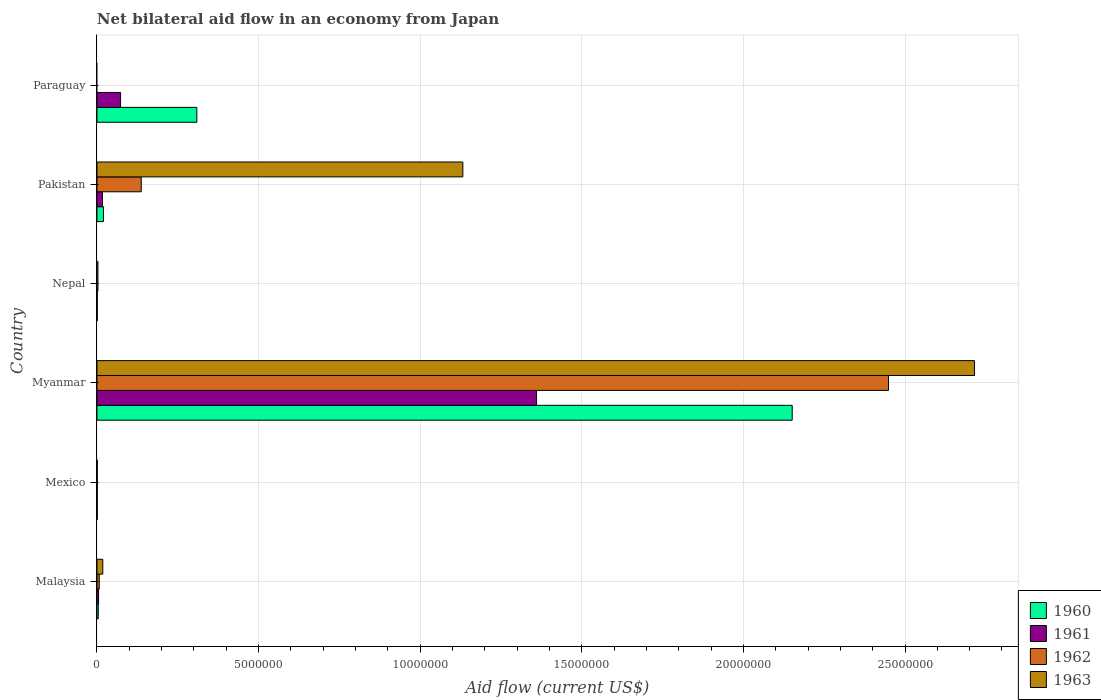Are the number of bars on each tick of the Y-axis equal?
Offer a very short reply. No. How many bars are there on the 5th tick from the top?
Keep it short and to the point. 4. How many bars are there on the 5th tick from the bottom?
Your answer should be compact. 4. What is the label of the 4th group of bars from the top?
Make the answer very short. Myanmar. In how many cases, is the number of bars for a given country not equal to the number of legend labels?
Make the answer very short. 1. What is the net bilateral aid flow in 1961 in Paraguay?
Give a very brief answer. 7.30e+05. Across all countries, what is the maximum net bilateral aid flow in 1960?
Make the answer very short. 2.15e+07. In which country was the net bilateral aid flow in 1960 maximum?
Provide a succinct answer. Myanmar. What is the total net bilateral aid flow in 1962 in the graph?
Give a very brief answer. 2.60e+07. What is the difference between the net bilateral aid flow in 1961 in Myanmar and the net bilateral aid flow in 1960 in Pakistan?
Your answer should be compact. 1.34e+07. What is the average net bilateral aid flow in 1961 per country?
Provide a short and direct response. 2.43e+06. What is the difference between the net bilateral aid flow in 1962 and net bilateral aid flow in 1960 in Myanmar?
Your answer should be compact. 2.98e+06. What is the ratio of the net bilateral aid flow in 1961 in Malaysia to that in Myanmar?
Your answer should be very brief. 0. Is the difference between the net bilateral aid flow in 1962 in Malaysia and Mexico greater than the difference between the net bilateral aid flow in 1960 in Malaysia and Mexico?
Your answer should be very brief. Yes. What is the difference between the highest and the second highest net bilateral aid flow in 1962?
Offer a very short reply. 2.31e+07. What is the difference between the highest and the lowest net bilateral aid flow in 1962?
Provide a short and direct response. 2.45e+07. In how many countries, is the net bilateral aid flow in 1960 greater than the average net bilateral aid flow in 1960 taken over all countries?
Your response must be concise. 1. Is it the case that in every country, the sum of the net bilateral aid flow in 1963 and net bilateral aid flow in 1962 is greater than the sum of net bilateral aid flow in 1961 and net bilateral aid flow in 1960?
Your answer should be very brief. No. How many bars are there?
Your answer should be compact. 22. Are all the bars in the graph horizontal?
Your answer should be compact. Yes. How many countries are there in the graph?
Provide a short and direct response. 6. What is the difference between two consecutive major ticks on the X-axis?
Your response must be concise. 5.00e+06. Does the graph contain any zero values?
Provide a succinct answer. Yes. Does the graph contain grids?
Your response must be concise. Yes. Where does the legend appear in the graph?
Provide a short and direct response. Bottom right. How many legend labels are there?
Ensure brevity in your answer.  4. How are the legend labels stacked?
Provide a succinct answer. Vertical. What is the title of the graph?
Your answer should be compact. Net bilateral aid flow in an economy from Japan. Does "1991" appear as one of the legend labels in the graph?
Keep it short and to the point. No. What is the label or title of the X-axis?
Provide a short and direct response. Aid flow (current US$). What is the label or title of the Y-axis?
Your response must be concise. Country. What is the Aid flow (current US$) in 1960 in Malaysia?
Give a very brief answer. 4.00e+04. What is the Aid flow (current US$) in 1962 in Malaysia?
Your answer should be compact. 7.00e+04. What is the Aid flow (current US$) in 1963 in Mexico?
Your answer should be very brief. 10000. What is the Aid flow (current US$) of 1960 in Myanmar?
Ensure brevity in your answer.  2.15e+07. What is the Aid flow (current US$) in 1961 in Myanmar?
Offer a very short reply. 1.36e+07. What is the Aid flow (current US$) in 1962 in Myanmar?
Provide a short and direct response. 2.45e+07. What is the Aid flow (current US$) in 1963 in Myanmar?
Your answer should be very brief. 2.72e+07. What is the Aid flow (current US$) of 1961 in Nepal?
Your response must be concise. 10000. What is the Aid flow (current US$) in 1963 in Nepal?
Provide a succinct answer. 3.00e+04. What is the Aid flow (current US$) in 1960 in Pakistan?
Provide a short and direct response. 2.00e+05. What is the Aid flow (current US$) in 1962 in Pakistan?
Your answer should be very brief. 1.37e+06. What is the Aid flow (current US$) in 1963 in Pakistan?
Your answer should be very brief. 1.13e+07. What is the Aid flow (current US$) of 1960 in Paraguay?
Provide a short and direct response. 3.09e+06. What is the Aid flow (current US$) of 1961 in Paraguay?
Your answer should be very brief. 7.30e+05. What is the Aid flow (current US$) in 1962 in Paraguay?
Your response must be concise. 0. Across all countries, what is the maximum Aid flow (current US$) of 1960?
Make the answer very short. 2.15e+07. Across all countries, what is the maximum Aid flow (current US$) in 1961?
Your answer should be very brief. 1.36e+07. Across all countries, what is the maximum Aid flow (current US$) of 1962?
Your response must be concise. 2.45e+07. Across all countries, what is the maximum Aid flow (current US$) in 1963?
Give a very brief answer. 2.72e+07. Across all countries, what is the minimum Aid flow (current US$) of 1961?
Provide a succinct answer. 10000. What is the total Aid flow (current US$) in 1960 in the graph?
Your answer should be very brief. 2.49e+07. What is the total Aid flow (current US$) of 1961 in the graph?
Your answer should be very brief. 1.46e+07. What is the total Aid flow (current US$) in 1962 in the graph?
Make the answer very short. 2.60e+07. What is the total Aid flow (current US$) of 1963 in the graph?
Provide a succinct answer. 3.87e+07. What is the difference between the Aid flow (current US$) of 1960 in Malaysia and that in Mexico?
Your answer should be compact. 3.00e+04. What is the difference between the Aid flow (current US$) of 1962 in Malaysia and that in Mexico?
Give a very brief answer. 6.00e+04. What is the difference between the Aid flow (current US$) in 1963 in Malaysia and that in Mexico?
Give a very brief answer. 1.70e+05. What is the difference between the Aid flow (current US$) in 1960 in Malaysia and that in Myanmar?
Keep it short and to the point. -2.15e+07. What is the difference between the Aid flow (current US$) in 1961 in Malaysia and that in Myanmar?
Make the answer very short. -1.36e+07. What is the difference between the Aid flow (current US$) in 1962 in Malaysia and that in Myanmar?
Make the answer very short. -2.44e+07. What is the difference between the Aid flow (current US$) in 1963 in Malaysia and that in Myanmar?
Make the answer very short. -2.70e+07. What is the difference between the Aid flow (current US$) of 1963 in Malaysia and that in Nepal?
Offer a very short reply. 1.50e+05. What is the difference between the Aid flow (current US$) in 1962 in Malaysia and that in Pakistan?
Ensure brevity in your answer.  -1.30e+06. What is the difference between the Aid flow (current US$) in 1963 in Malaysia and that in Pakistan?
Keep it short and to the point. -1.11e+07. What is the difference between the Aid flow (current US$) in 1960 in Malaysia and that in Paraguay?
Your answer should be compact. -3.05e+06. What is the difference between the Aid flow (current US$) of 1961 in Malaysia and that in Paraguay?
Your response must be concise. -6.80e+05. What is the difference between the Aid flow (current US$) in 1960 in Mexico and that in Myanmar?
Provide a succinct answer. -2.15e+07. What is the difference between the Aid flow (current US$) in 1961 in Mexico and that in Myanmar?
Make the answer very short. -1.36e+07. What is the difference between the Aid flow (current US$) in 1962 in Mexico and that in Myanmar?
Keep it short and to the point. -2.45e+07. What is the difference between the Aid flow (current US$) in 1963 in Mexico and that in Myanmar?
Make the answer very short. -2.71e+07. What is the difference between the Aid flow (current US$) in 1960 in Mexico and that in Nepal?
Your answer should be very brief. 0. What is the difference between the Aid flow (current US$) in 1962 in Mexico and that in Nepal?
Ensure brevity in your answer.  -2.00e+04. What is the difference between the Aid flow (current US$) of 1961 in Mexico and that in Pakistan?
Offer a terse response. -1.60e+05. What is the difference between the Aid flow (current US$) of 1962 in Mexico and that in Pakistan?
Provide a short and direct response. -1.36e+06. What is the difference between the Aid flow (current US$) in 1963 in Mexico and that in Pakistan?
Make the answer very short. -1.13e+07. What is the difference between the Aid flow (current US$) of 1960 in Mexico and that in Paraguay?
Offer a very short reply. -3.08e+06. What is the difference between the Aid flow (current US$) of 1961 in Mexico and that in Paraguay?
Make the answer very short. -7.20e+05. What is the difference between the Aid flow (current US$) of 1960 in Myanmar and that in Nepal?
Provide a short and direct response. 2.15e+07. What is the difference between the Aid flow (current US$) of 1961 in Myanmar and that in Nepal?
Give a very brief answer. 1.36e+07. What is the difference between the Aid flow (current US$) of 1962 in Myanmar and that in Nepal?
Your response must be concise. 2.45e+07. What is the difference between the Aid flow (current US$) of 1963 in Myanmar and that in Nepal?
Keep it short and to the point. 2.71e+07. What is the difference between the Aid flow (current US$) of 1960 in Myanmar and that in Pakistan?
Provide a succinct answer. 2.13e+07. What is the difference between the Aid flow (current US$) of 1961 in Myanmar and that in Pakistan?
Give a very brief answer. 1.34e+07. What is the difference between the Aid flow (current US$) in 1962 in Myanmar and that in Pakistan?
Make the answer very short. 2.31e+07. What is the difference between the Aid flow (current US$) in 1963 in Myanmar and that in Pakistan?
Your response must be concise. 1.58e+07. What is the difference between the Aid flow (current US$) of 1960 in Myanmar and that in Paraguay?
Keep it short and to the point. 1.84e+07. What is the difference between the Aid flow (current US$) in 1961 in Myanmar and that in Paraguay?
Provide a succinct answer. 1.29e+07. What is the difference between the Aid flow (current US$) of 1960 in Nepal and that in Pakistan?
Give a very brief answer. -1.90e+05. What is the difference between the Aid flow (current US$) of 1962 in Nepal and that in Pakistan?
Provide a short and direct response. -1.34e+06. What is the difference between the Aid flow (current US$) of 1963 in Nepal and that in Pakistan?
Your response must be concise. -1.13e+07. What is the difference between the Aid flow (current US$) in 1960 in Nepal and that in Paraguay?
Your answer should be compact. -3.08e+06. What is the difference between the Aid flow (current US$) of 1961 in Nepal and that in Paraguay?
Your answer should be very brief. -7.20e+05. What is the difference between the Aid flow (current US$) of 1960 in Pakistan and that in Paraguay?
Make the answer very short. -2.89e+06. What is the difference between the Aid flow (current US$) of 1961 in Pakistan and that in Paraguay?
Your response must be concise. -5.60e+05. What is the difference between the Aid flow (current US$) of 1960 in Malaysia and the Aid flow (current US$) of 1961 in Mexico?
Your answer should be very brief. 3.00e+04. What is the difference between the Aid flow (current US$) of 1960 in Malaysia and the Aid flow (current US$) of 1962 in Mexico?
Offer a terse response. 3.00e+04. What is the difference between the Aid flow (current US$) in 1960 in Malaysia and the Aid flow (current US$) in 1963 in Mexico?
Your response must be concise. 3.00e+04. What is the difference between the Aid flow (current US$) in 1960 in Malaysia and the Aid flow (current US$) in 1961 in Myanmar?
Ensure brevity in your answer.  -1.36e+07. What is the difference between the Aid flow (current US$) in 1960 in Malaysia and the Aid flow (current US$) in 1962 in Myanmar?
Keep it short and to the point. -2.44e+07. What is the difference between the Aid flow (current US$) of 1960 in Malaysia and the Aid flow (current US$) of 1963 in Myanmar?
Your answer should be very brief. -2.71e+07. What is the difference between the Aid flow (current US$) in 1961 in Malaysia and the Aid flow (current US$) in 1962 in Myanmar?
Keep it short and to the point. -2.44e+07. What is the difference between the Aid flow (current US$) in 1961 in Malaysia and the Aid flow (current US$) in 1963 in Myanmar?
Offer a very short reply. -2.71e+07. What is the difference between the Aid flow (current US$) of 1962 in Malaysia and the Aid flow (current US$) of 1963 in Myanmar?
Provide a short and direct response. -2.71e+07. What is the difference between the Aid flow (current US$) in 1960 in Malaysia and the Aid flow (current US$) in 1961 in Nepal?
Provide a succinct answer. 3.00e+04. What is the difference between the Aid flow (current US$) of 1961 in Malaysia and the Aid flow (current US$) of 1963 in Nepal?
Give a very brief answer. 2.00e+04. What is the difference between the Aid flow (current US$) in 1962 in Malaysia and the Aid flow (current US$) in 1963 in Nepal?
Ensure brevity in your answer.  4.00e+04. What is the difference between the Aid flow (current US$) of 1960 in Malaysia and the Aid flow (current US$) of 1961 in Pakistan?
Provide a succinct answer. -1.30e+05. What is the difference between the Aid flow (current US$) of 1960 in Malaysia and the Aid flow (current US$) of 1962 in Pakistan?
Keep it short and to the point. -1.33e+06. What is the difference between the Aid flow (current US$) of 1960 in Malaysia and the Aid flow (current US$) of 1963 in Pakistan?
Your response must be concise. -1.13e+07. What is the difference between the Aid flow (current US$) in 1961 in Malaysia and the Aid flow (current US$) in 1962 in Pakistan?
Offer a very short reply. -1.32e+06. What is the difference between the Aid flow (current US$) of 1961 in Malaysia and the Aid flow (current US$) of 1963 in Pakistan?
Provide a short and direct response. -1.13e+07. What is the difference between the Aid flow (current US$) in 1962 in Malaysia and the Aid flow (current US$) in 1963 in Pakistan?
Your response must be concise. -1.12e+07. What is the difference between the Aid flow (current US$) in 1960 in Malaysia and the Aid flow (current US$) in 1961 in Paraguay?
Keep it short and to the point. -6.90e+05. What is the difference between the Aid flow (current US$) of 1960 in Mexico and the Aid flow (current US$) of 1961 in Myanmar?
Your answer should be compact. -1.36e+07. What is the difference between the Aid flow (current US$) of 1960 in Mexico and the Aid flow (current US$) of 1962 in Myanmar?
Your response must be concise. -2.45e+07. What is the difference between the Aid flow (current US$) in 1960 in Mexico and the Aid flow (current US$) in 1963 in Myanmar?
Your answer should be very brief. -2.71e+07. What is the difference between the Aid flow (current US$) of 1961 in Mexico and the Aid flow (current US$) of 1962 in Myanmar?
Provide a short and direct response. -2.45e+07. What is the difference between the Aid flow (current US$) in 1961 in Mexico and the Aid flow (current US$) in 1963 in Myanmar?
Ensure brevity in your answer.  -2.71e+07. What is the difference between the Aid flow (current US$) in 1962 in Mexico and the Aid flow (current US$) in 1963 in Myanmar?
Offer a very short reply. -2.71e+07. What is the difference between the Aid flow (current US$) in 1960 in Mexico and the Aid flow (current US$) in 1962 in Nepal?
Offer a very short reply. -2.00e+04. What is the difference between the Aid flow (current US$) in 1960 in Mexico and the Aid flow (current US$) in 1963 in Nepal?
Provide a succinct answer. -2.00e+04. What is the difference between the Aid flow (current US$) of 1961 in Mexico and the Aid flow (current US$) of 1963 in Nepal?
Your answer should be very brief. -2.00e+04. What is the difference between the Aid flow (current US$) in 1960 in Mexico and the Aid flow (current US$) in 1962 in Pakistan?
Offer a very short reply. -1.36e+06. What is the difference between the Aid flow (current US$) in 1960 in Mexico and the Aid flow (current US$) in 1963 in Pakistan?
Give a very brief answer. -1.13e+07. What is the difference between the Aid flow (current US$) of 1961 in Mexico and the Aid flow (current US$) of 1962 in Pakistan?
Offer a very short reply. -1.36e+06. What is the difference between the Aid flow (current US$) of 1961 in Mexico and the Aid flow (current US$) of 1963 in Pakistan?
Offer a very short reply. -1.13e+07. What is the difference between the Aid flow (current US$) in 1962 in Mexico and the Aid flow (current US$) in 1963 in Pakistan?
Ensure brevity in your answer.  -1.13e+07. What is the difference between the Aid flow (current US$) in 1960 in Mexico and the Aid flow (current US$) in 1961 in Paraguay?
Your answer should be very brief. -7.20e+05. What is the difference between the Aid flow (current US$) in 1960 in Myanmar and the Aid flow (current US$) in 1961 in Nepal?
Your answer should be very brief. 2.15e+07. What is the difference between the Aid flow (current US$) of 1960 in Myanmar and the Aid flow (current US$) of 1962 in Nepal?
Give a very brief answer. 2.15e+07. What is the difference between the Aid flow (current US$) of 1960 in Myanmar and the Aid flow (current US$) of 1963 in Nepal?
Your response must be concise. 2.15e+07. What is the difference between the Aid flow (current US$) of 1961 in Myanmar and the Aid flow (current US$) of 1962 in Nepal?
Provide a short and direct response. 1.36e+07. What is the difference between the Aid flow (current US$) in 1961 in Myanmar and the Aid flow (current US$) in 1963 in Nepal?
Give a very brief answer. 1.36e+07. What is the difference between the Aid flow (current US$) of 1962 in Myanmar and the Aid flow (current US$) of 1963 in Nepal?
Ensure brevity in your answer.  2.45e+07. What is the difference between the Aid flow (current US$) of 1960 in Myanmar and the Aid flow (current US$) of 1961 in Pakistan?
Keep it short and to the point. 2.13e+07. What is the difference between the Aid flow (current US$) of 1960 in Myanmar and the Aid flow (current US$) of 1962 in Pakistan?
Your answer should be very brief. 2.01e+07. What is the difference between the Aid flow (current US$) in 1960 in Myanmar and the Aid flow (current US$) in 1963 in Pakistan?
Your answer should be compact. 1.02e+07. What is the difference between the Aid flow (current US$) of 1961 in Myanmar and the Aid flow (current US$) of 1962 in Pakistan?
Offer a very short reply. 1.22e+07. What is the difference between the Aid flow (current US$) of 1961 in Myanmar and the Aid flow (current US$) of 1963 in Pakistan?
Ensure brevity in your answer.  2.28e+06. What is the difference between the Aid flow (current US$) in 1962 in Myanmar and the Aid flow (current US$) in 1963 in Pakistan?
Your answer should be compact. 1.32e+07. What is the difference between the Aid flow (current US$) in 1960 in Myanmar and the Aid flow (current US$) in 1961 in Paraguay?
Make the answer very short. 2.08e+07. What is the difference between the Aid flow (current US$) in 1960 in Nepal and the Aid flow (current US$) in 1961 in Pakistan?
Your answer should be very brief. -1.60e+05. What is the difference between the Aid flow (current US$) in 1960 in Nepal and the Aid flow (current US$) in 1962 in Pakistan?
Your answer should be compact. -1.36e+06. What is the difference between the Aid flow (current US$) of 1960 in Nepal and the Aid flow (current US$) of 1963 in Pakistan?
Offer a terse response. -1.13e+07. What is the difference between the Aid flow (current US$) of 1961 in Nepal and the Aid flow (current US$) of 1962 in Pakistan?
Offer a very short reply. -1.36e+06. What is the difference between the Aid flow (current US$) in 1961 in Nepal and the Aid flow (current US$) in 1963 in Pakistan?
Offer a very short reply. -1.13e+07. What is the difference between the Aid flow (current US$) of 1962 in Nepal and the Aid flow (current US$) of 1963 in Pakistan?
Ensure brevity in your answer.  -1.13e+07. What is the difference between the Aid flow (current US$) of 1960 in Nepal and the Aid flow (current US$) of 1961 in Paraguay?
Offer a terse response. -7.20e+05. What is the difference between the Aid flow (current US$) in 1960 in Pakistan and the Aid flow (current US$) in 1961 in Paraguay?
Your response must be concise. -5.30e+05. What is the average Aid flow (current US$) in 1960 per country?
Give a very brief answer. 4.14e+06. What is the average Aid flow (current US$) in 1961 per country?
Make the answer very short. 2.43e+06. What is the average Aid flow (current US$) of 1962 per country?
Your answer should be very brief. 4.33e+06. What is the average Aid flow (current US$) of 1963 per country?
Give a very brief answer. 6.45e+06. What is the difference between the Aid flow (current US$) of 1960 and Aid flow (current US$) of 1963 in Malaysia?
Give a very brief answer. -1.40e+05. What is the difference between the Aid flow (current US$) in 1962 and Aid flow (current US$) in 1963 in Malaysia?
Give a very brief answer. -1.10e+05. What is the difference between the Aid flow (current US$) of 1960 and Aid flow (current US$) of 1961 in Mexico?
Your answer should be very brief. 0. What is the difference between the Aid flow (current US$) of 1960 and Aid flow (current US$) of 1962 in Mexico?
Provide a short and direct response. 0. What is the difference between the Aid flow (current US$) in 1960 and Aid flow (current US$) in 1963 in Mexico?
Your answer should be compact. 0. What is the difference between the Aid flow (current US$) of 1961 and Aid flow (current US$) of 1962 in Mexico?
Offer a very short reply. 0. What is the difference between the Aid flow (current US$) of 1961 and Aid flow (current US$) of 1963 in Mexico?
Your response must be concise. 0. What is the difference between the Aid flow (current US$) of 1960 and Aid flow (current US$) of 1961 in Myanmar?
Provide a succinct answer. 7.91e+06. What is the difference between the Aid flow (current US$) of 1960 and Aid flow (current US$) of 1962 in Myanmar?
Your answer should be compact. -2.98e+06. What is the difference between the Aid flow (current US$) of 1960 and Aid flow (current US$) of 1963 in Myanmar?
Offer a very short reply. -5.64e+06. What is the difference between the Aid flow (current US$) in 1961 and Aid flow (current US$) in 1962 in Myanmar?
Your answer should be compact. -1.09e+07. What is the difference between the Aid flow (current US$) of 1961 and Aid flow (current US$) of 1963 in Myanmar?
Offer a terse response. -1.36e+07. What is the difference between the Aid flow (current US$) of 1962 and Aid flow (current US$) of 1963 in Myanmar?
Keep it short and to the point. -2.66e+06. What is the difference between the Aid flow (current US$) of 1960 and Aid flow (current US$) of 1961 in Nepal?
Your response must be concise. 0. What is the difference between the Aid flow (current US$) of 1961 and Aid flow (current US$) of 1962 in Nepal?
Give a very brief answer. -2.00e+04. What is the difference between the Aid flow (current US$) in 1962 and Aid flow (current US$) in 1963 in Nepal?
Make the answer very short. 0. What is the difference between the Aid flow (current US$) of 1960 and Aid flow (current US$) of 1961 in Pakistan?
Your answer should be compact. 3.00e+04. What is the difference between the Aid flow (current US$) of 1960 and Aid flow (current US$) of 1962 in Pakistan?
Provide a short and direct response. -1.17e+06. What is the difference between the Aid flow (current US$) of 1960 and Aid flow (current US$) of 1963 in Pakistan?
Provide a short and direct response. -1.11e+07. What is the difference between the Aid flow (current US$) of 1961 and Aid flow (current US$) of 1962 in Pakistan?
Ensure brevity in your answer.  -1.20e+06. What is the difference between the Aid flow (current US$) in 1961 and Aid flow (current US$) in 1963 in Pakistan?
Provide a succinct answer. -1.12e+07. What is the difference between the Aid flow (current US$) in 1962 and Aid flow (current US$) in 1963 in Pakistan?
Ensure brevity in your answer.  -9.95e+06. What is the difference between the Aid flow (current US$) of 1960 and Aid flow (current US$) of 1961 in Paraguay?
Offer a very short reply. 2.36e+06. What is the ratio of the Aid flow (current US$) in 1961 in Malaysia to that in Mexico?
Provide a succinct answer. 5. What is the ratio of the Aid flow (current US$) of 1963 in Malaysia to that in Mexico?
Offer a very short reply. 18. What is the ratio of the Aid flow (current US$) of 1960 in Malaysia to that in Myanmar?
Provide a short and direct response. 0. What is the ratio of the Aid flow (current US$) in 1961 in Malaysia to that in Myanmar?
Your response must be concise. 0. What is the ratio of the Aid flow (current US$) in 1962 in Malaysia to that in Myanmar?
Offer a terse response. 0. What is the ratio of the Aid flow (current US$) of 1963 in Malaysia to that in Myanmar?
Make the answer very short. 0.01. What is the ratio of the Aid flow (current US$) in 1960 in Malaysia to that in Nepal?
Offer a very short reply. 4. What is the ratio of the Aid flow (current US$) in 1962 in Malaysia to that in Nepal?
Your answer should be very brief. 2.33. What is the ratio of the Aid flow (current US$) in 1961 in Malaysia to that in Pakistan?
Make the answer very short. 0.29. What is the ratio of the Aid flow (current US$) in 1962 in Malaysia to that in Pakistan?
Keep it short and to the point. 0.05. What is the ratio of the Aid flow (current US$) of 1963 in Malaysia to that in Pakistan?
Give a very brief answer. 0.02. What is the ratio of the Aid flow (current US$) of 1960 in Malaysia to that in Paraguay?
Provide a short and direct response. 0.01. What is the ratio of the Aid flow (current US$) in 1961 in Malaysia to that in Paraguay?
Your answer should be compact. 0.07. What is the ratio of the Aid flow (current US$) of 1961 in Mexico to that in Myanmar?
Ensure brevity in your answer.  0. What is the ratio of the Aid flow (current US$) in 1961 in Mexico to that in Nepal?
Make the answer very short. 1. What is the ratio of the Aid flow (current US$) of 1962 in Mexico to that in Nepal?
Your answer should be very brief. 0.33. What is the ratio of the Aid flow (current US$) in 1963 in Mexico to that in Nepal?
Keep it short and to the point. 0.33. What is the ratio of the Aid flow (current US$) in 1961 in Mexico to that in Pakistan?
Provide a succinct answer. 0.06. What is the ratio of the Aid flow (current US$) of 1962 in Mexico to that in Pakistan?
Ensure brevity in your answer.  0.01. What is the ratio of the Aid flow (current US$) in 1963 in Mexico to that in Pakistan?
Ensure brevity in your answer.  0. What is the ratio of the Aid flow (current US$) of 1960 in Mexico to that in Paraguay?
Your response must be concise. 0. What is the ratio of the Aid flow (current US$) of 1961 in Mexico to that in Paraguay?
Give a very brief answer. 0.01. What is the ratio of the Aid flow (current US$) in 1960 in Myanmar to that in Nepal?
Offer a very short reply. 2151. What is the ratio of the Aid flow (current US$) in 1961 in Myanmar to that in Nepal?
Provide a short and direct response. 1360. What is the ratio of the Aid flow (current US$) in 1962 in Myanmar to that in Nepal?
Keep it short and to the point. 816.33. What is the ratio of the Aid flow (current US$) of 1963 in Myanmar to that in Nepal?
Your answer should be compact. 905. What is the ratio of the Aid flow (current US$) in 1960 in Myanmar to that in Pakistan?
Provide a succinct answer. 107.55. What is the ratio of the Aid flow (current US$) of 1961 in Myanmar to that in Pakistan?
Give a very brief answer. 80. What is the ratio of the Aid flow (current US$) in 1962 in Myanmar to that in Pakistan?
Offer a terse response. 17.88. What is the ratio of the Aid flow (current US$) of 1963 in Myanmar to that in Pakistan?
Your response must be concise. 2.4. What is the ratio of the Aid flow (current US$) in 1960 in Myanmar to that in Paraguay?
Offer a terse response. 6.96. What is the ratio of the Aid flow (current US$) of 1961 in Myanmar to that in Paraguay?
Your response must be concise. 18.63. What is the ratio of the Aid flow (current US$) of 1960 in Nepal to that in Pakistan?
Keep it short and to the point. 0.05. What is the ratio of the Aid flow (current US$) in 1961 in Nepal to that in Pakistan?
Keep it short and to the point. 0.06. What is the ratio of the Aid flow (current US$) in 1962 in Nepal to that in Pakistan?
Offer a terse response. 0.02. What is the ratio of the Aid flow (current US$) of 1963 in Nepal to that in Pakistan?
Your answer should be very brief. 0. What is the ratio of the Aid flow (current US$) of 1960 in Nepal to that in Paraguay?
Offer a very short reply. 0. What is the ratio of the Aid flow (current US$) in 1961 in Nepal to that in Paraguay?
Your answer should be very brief. 0.01. What is the ratio of the Aid flow (current US$) in 1960 in Pakistan to that in Paraguay?
Keep it short and to the point. 0.06. What is the ratio of the Aid flow (current US$) of 1961 in Pakistan to that in Paraguay?
Your response must be concise. 0.23. What is the difference between the highest and the second highest Aid flow (current US$) of 1960?
Offer a terse response. 1.84e+07. What is the difference between the highest and the second highest Aid flow (current US$) in 1961?
Your answer should be compact. 1.29e+07. What is the difference between the highest and the second highest Aid flow (current US$) of 1962?
Provide a succinct answer. 2.31e+07. What is the difference between the highest and the second highest Aid flow (current US$) in 1963?
Keep it short and to the point. 1.58e+07. What is the difference between the highest and the lowest Aid flow (current US$) of 1960?
Your answer should be very brief. 2.15e+07. What is the difference between the highest and the lowest Aid flow (current US$) of 1961?
Ensure brevity in your answer.  1.36e+07. What is the difference between the highest and the lowest Aid flow (current US$) of 1962?
Your answer should be compact. 2.45e+07. What is the difference between the highest and the lowest Aid flow (current US$) of 1963?
Your response must be concise. 2.72e+07. 